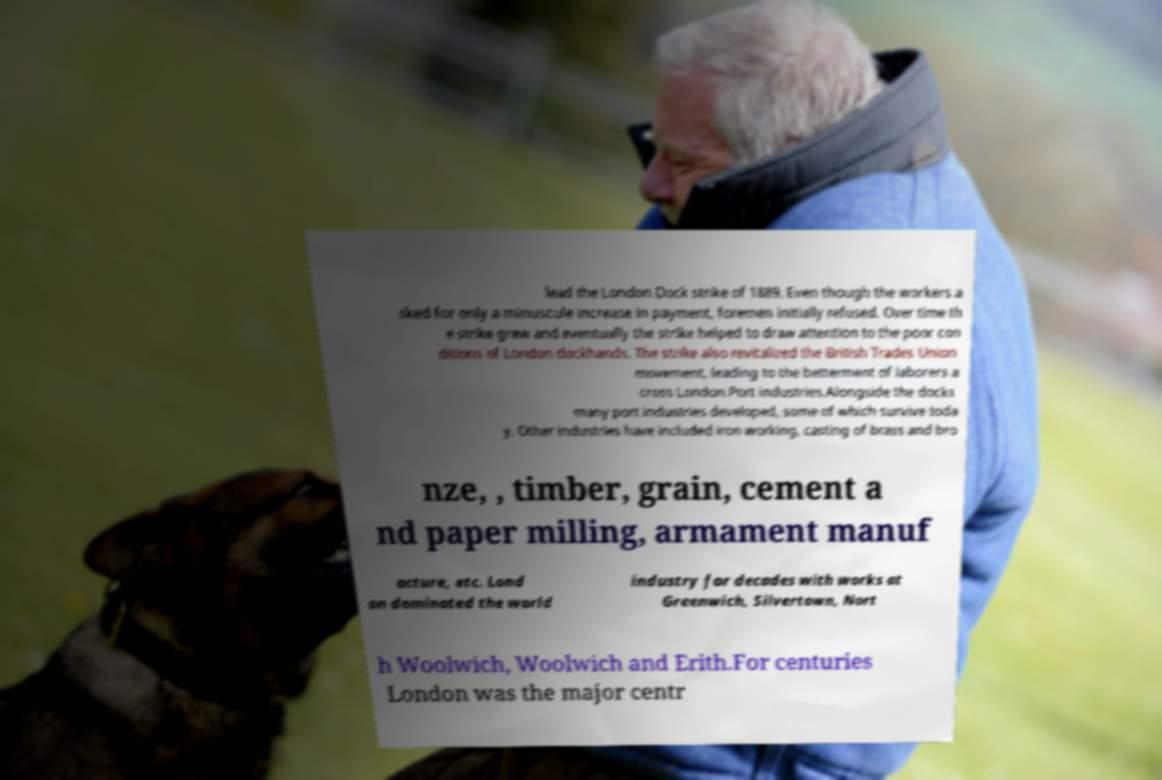What messages or text are displayed in this image? I need them in a readable, typed format. lead the London Dock strike of 1889. Even though the workers a sked for only a minuscule increase in payment, foremen initially refused. Over time th e strike grew and eventually the strike helped to draw attention to the poor con ditions of London dockhands. The strike also revitalized the British Trades Union movement, leading to the betterment of laborers a cross London.Port industries.Alongside the docks many port industries developed, some of which survive toda y. Other industries have included iron working, casting of brass and bro nze, , timber, grain, cement a nd paper milling, armament manuf acture, etc. Lond on dominated the world industry for decades with works at Greenwich, Silvertown, Nort h Woolwich, Woolwich and Erith.For centuries London was the major centr 